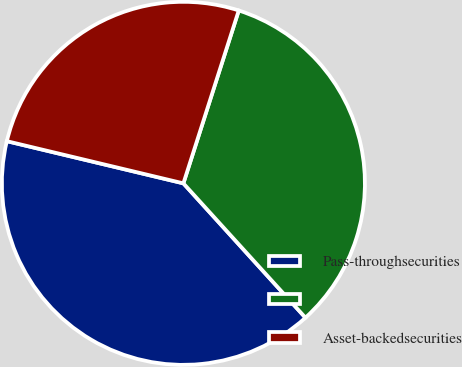Convert chart to OTSL. <chart><loc_0><loc_0><loc_500><loc_500><pie_chart><fcel>Pass-throughsecurities<fcel>Unnamed: 1<fcel>Asset-backedsecurities<nl><fcel>40.47%<fcel>33.33%<fcel>26.2%<nl></chart> 